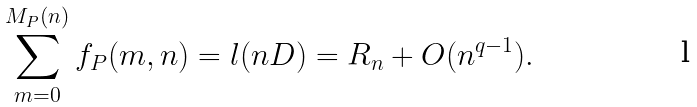Convert formula to latex. <formula><loc_0><loc_0><loc_500><loc_500>\sum _ { m = 0 } ^ { M _ { P } ( n ) } f _ { P } ( m , n ) = l ( n D ) = R _ { n } + O ( n ^ { q - 1 } ) .</formula> 